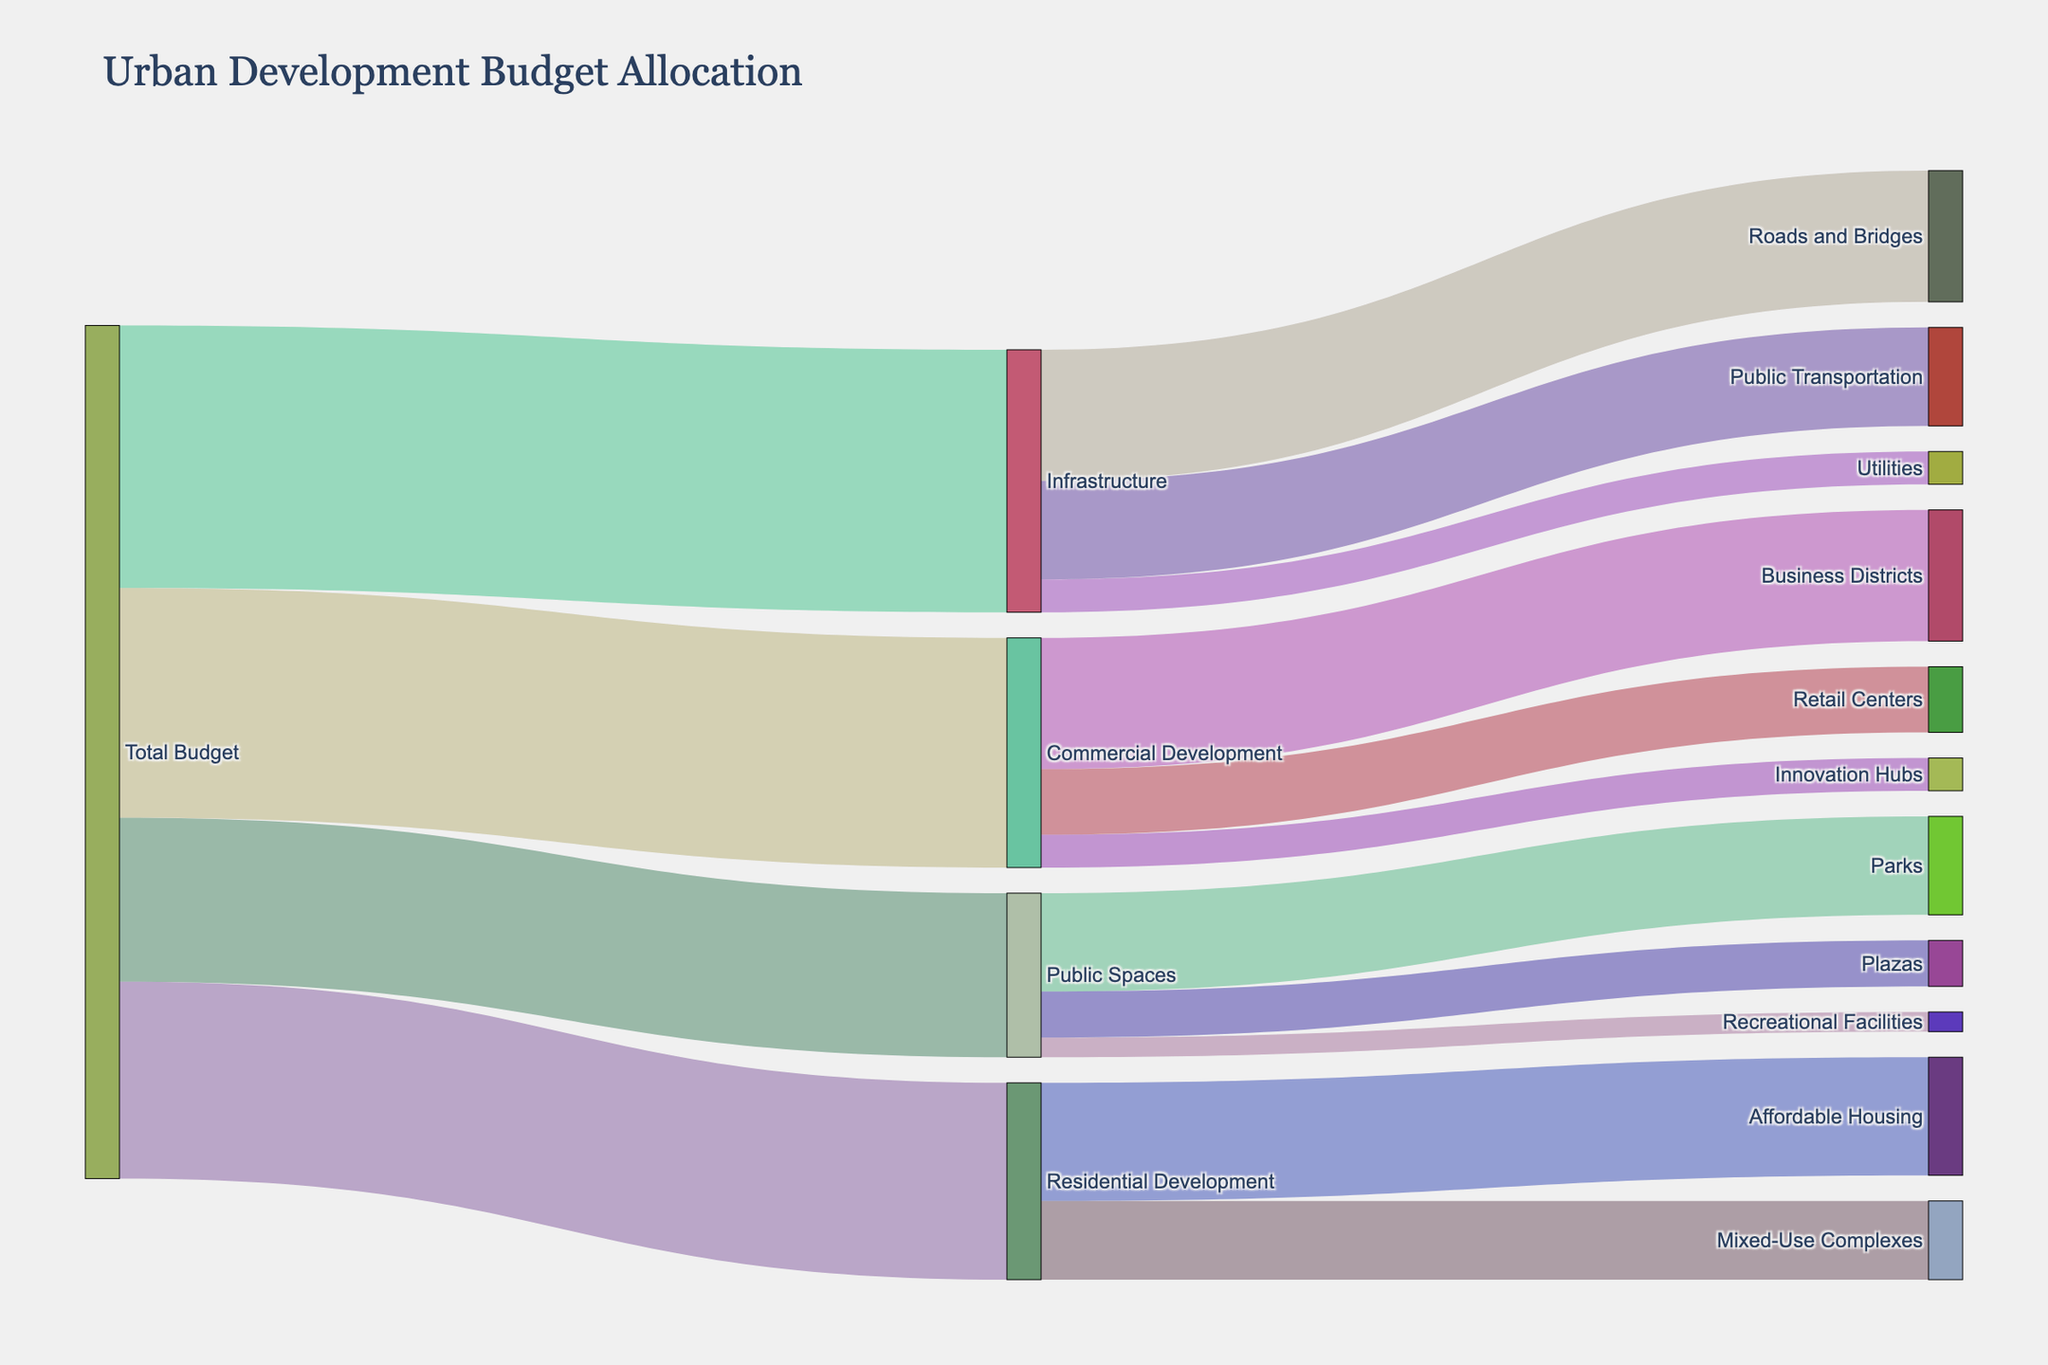what is the title of the figure? The title of the figure is displayed at the top of the Sankey diagram. It summarizes the purpose of the figure and helps the viewer understand the context at a glance.
Answer: Urban Development Budget Allocation how many main categories are the total budget divided into? The main categories are identified by looking at the first level of connections branching from the "Total Budget" node.
Answer: 4 which subcategory receives the highest allocation under infrastructure? To identify the highest allocation, compare the values associated with each subcategory under "Infrastructure".
Answer: Roads and Bridges what is the total budget for residential development subcategories? To find the total budget for residential development, sum the values allocated to "Affordable Housing" and "Mixed-Use Complexes".
Answer: 30000000 how much more budget is allocated to commercial development compared to public spaces? Find the difference in values allocated to "Commercial Development" and "Public Spaces" by subtracting the smaller value from the larger one.
Answer: 10000000 how do the budgets for parks and plazas under public spaces compare? Compare the individual values for "Parks" and "Plazas" under the "Public Spaces" category to determine which one is greater.
Answer: Parks have a larger budget which development category has the least budget allocated to its subcategories? Examine the total budget allocated to each main category by summing their respective subcategories and find the one with the smallest sum.
Answer: Public Spaces how are the budgets for public transportation and utilities under infrastructure different? Compare the values of "Public Transportation" and "Utilities" under "Infrastructure" to determine their difference.
Answer: Public Transportation has 10,000,000 more if innovation hubs receive an additional 5,000,000 in budget, what will be the new total allocation for commercial development? Add the additional 5,000,000 to the current allocation of "Innovation Hubs" and sum the total for "Commercial Development" again. New total = current total + additional budget.
Answer: 40000000 what percentage of the total budget is allocated to infrastructure? Divide the allocation to "Infrastructure" by the total budget and multiply by 100 to get the percentage. (40000000/130000000) * 100
Answer: Approximately 30.77% 